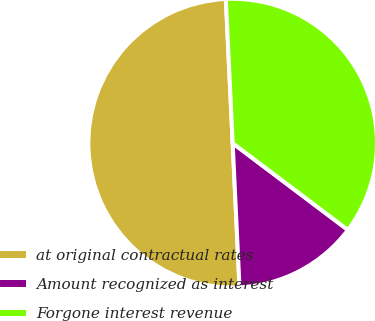Convert chart. <chart><loc_0><loc_0><loc_500><loc_500><pie_chart><fcel>at original contractual rates<fcel>Amount recognized as interest<fcel>Forgone interest revenue<nl><fcel>50.0%<fcel>13.97%<fcel>36.03%<nl></chart> 